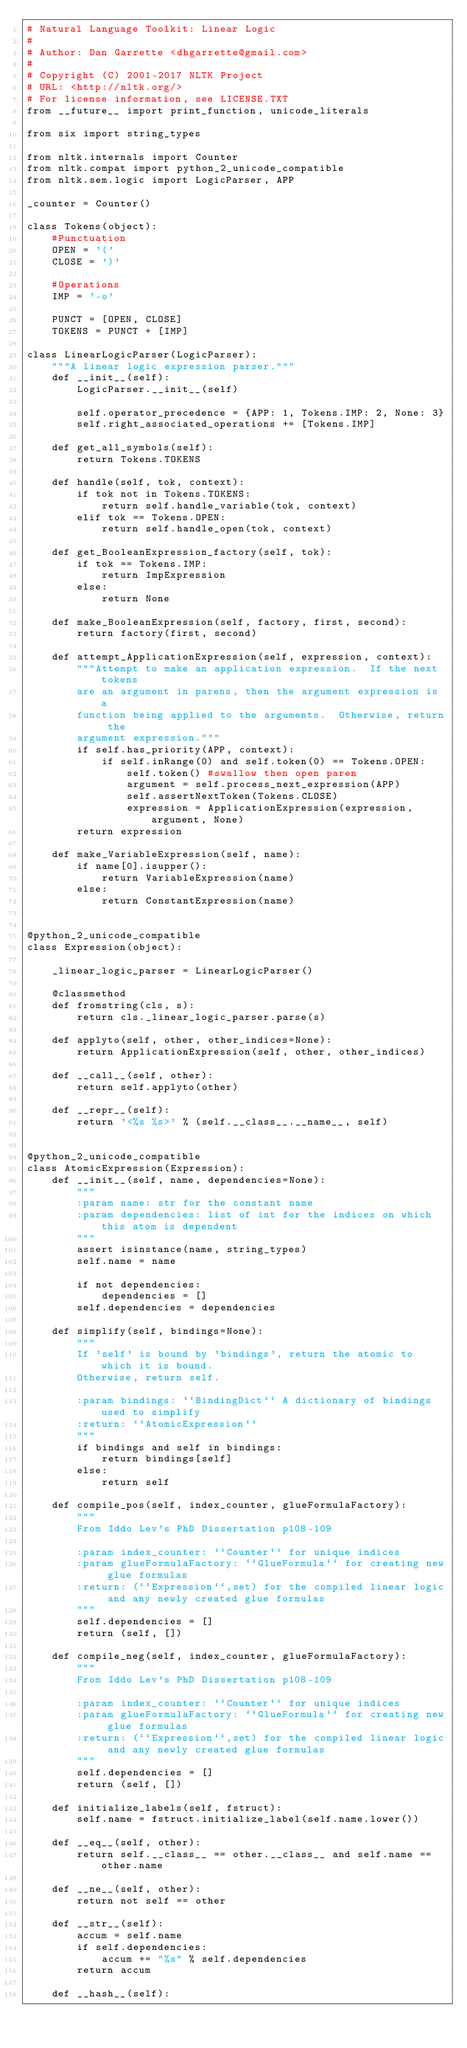<code> <loc_0><loc_0><loc_500><loc_500><_Python_># Natural Language Toolkit: Linear Logic
#
# Author: Dan Garrette <dhgarrette@gmail.com>
#
# Copyright (C) 2001-2017 NLTK Project
# URL: <http://nltk.org/>
# For license information, see LICENSE.TXT
from __future__ import print_function, unicode_literals

from six import string_types

from nltk.internals import Counter
from nltk.compat import python_2_unicode_compatible
from nltk.sem.logic import LogicParser, APP

_counter = Counter()

class Tokens(object):
    #Punctuation
    OPEN = '('
    CLOSE = ')'

    #Operations
    IMP = '-o'

    PUNCT = [OPEN, CLOSE]
    TOKENS = PUNCT + [IMP]

class LinearLogicParser(LogicParser):
    """A linear logic expression parser."""
    def __init__(self):
        LogicParser.__init__(self)

        self.operator_precedence = {APP: 1, Tokens.IMP: 2, None: 3}
        self.right_associated_operations += [Tokens.IMP]

    def get_all_symbols(self):
        return Tokens.TOKENS

    def handle(self, tok, context):
        if tok not in Tokens.TOKENS:
            return self.handle_variable(tok, context)
        elif tok == Tokens.OPEN:
            return self.handle_open(tok, context)

    def get_BooleanExpression_factory(self, tok):
        if tok == Tokens.IMP:
            return ImpExpression
        else:
            return None

    def make_BooleanExpression(self, factory, first, second):
        return factory(first, second)

    def attempt_ApplicationExpression(self, expression, context):
        """Attempt to make an application expression.  If the next tokens
        are an argument in parens, then the argument expression is a
        function being applied to the arguments.  Otherwise, return the
        argument expression."""
        if self.has_priority(APP, context):
            if self.inRange(0) and self.token(0) == Tokens.OPEN:
                self.token() #swallow then open paren
                argument = self.process_next_expression(APP)
                self.assertNextToken(Tokens.CLOSE)
                expression = ApplicationExpression(expression, argument, None)
        return expression

    def make_VariableExpression(self, name):
        if name[0].isupper():
            return VariableExpression(name)
        else:
            return ConstantExpression(name)


@python_2_unicode_compatible
class Expression(object):

    _linear_logic_parser = LinearLogicParser()

    @classmethod
    def fromstring(cls, s):
        return cls._linear_logic_parser.parse(s)

    def applyto(self, other, other_indices=None):
        return ApplicationExpression(self, other, other_indices)

    def __call__(self, other):
        return self.applyto(other)

    def __repr__(self):
        return '<%s %s>' % (self.__class__.__name__, self)


@python_2_unicode_compatible
class AtomicExpression(Expression):
    def __init__(self, name, dependencies=None):
        """
        :param name: str for the constant name
        :param dependencies: list of int for the indices on which this atom is dependent
        """
        assert isinstance(name, string_types)
        self.name = name

        if not dependencies:
            dependencies = []
        self.dependencies = dependencies

    def simplify(self, bindings=None):
        """
        If 'self' is bound by 'bindings', return the atomic to which it is bound.
        Otherwise, return self.

        :param bindings: ``BindingDict`` A dictionary of bindings used to simplify
        :return: ``AtomicExpression``
        """
        if bindings and self in bindings:
            return bindings[self]
        else:
            return self

    def compile_pos(self, index_counter, glueFormulaFactory):
        """
        From Iddo Lev's PhD Dissertation p108-109

        :param index_counter: ``Counter`` for unique indices
        :param glueFormulaFactory: ``GlueFormula`` for creating new glue formulas
        :return: (``Expression``,set) for the compiled linear logic and any newly created glue formulas
        """
        self.dependencies = []
        return (self, [])

    def compile_neg(self, index_counter, glueFormulaFactory):
        """
        From Iddo Lev's PhD Dissertation p108-109

        :param index_counter: ``Counter`` for unique indices
        :param glueFormulaFactory: ``GlueFormula`` for creating new glue formulas
        :return: (``Expression``,set) for the compiled linear logic and any newly created glue formulas
        """
        self.dependencies = []
        return (self, [])

    def initialize_labels(self, fstruct):
        self.name = fstruct.initialize_label(self.name.lower())

    def __eq__(self, other):
        return self.__class__ == other.__class__ and self.name == other.name

    def __ne__(self, other):
        return not self == other

    def __str__(self):
        accum = self.name
        if self.dependencies:
            accum += "%s" % self.dependencies
        return accum

    def __hash__(self):</code> 